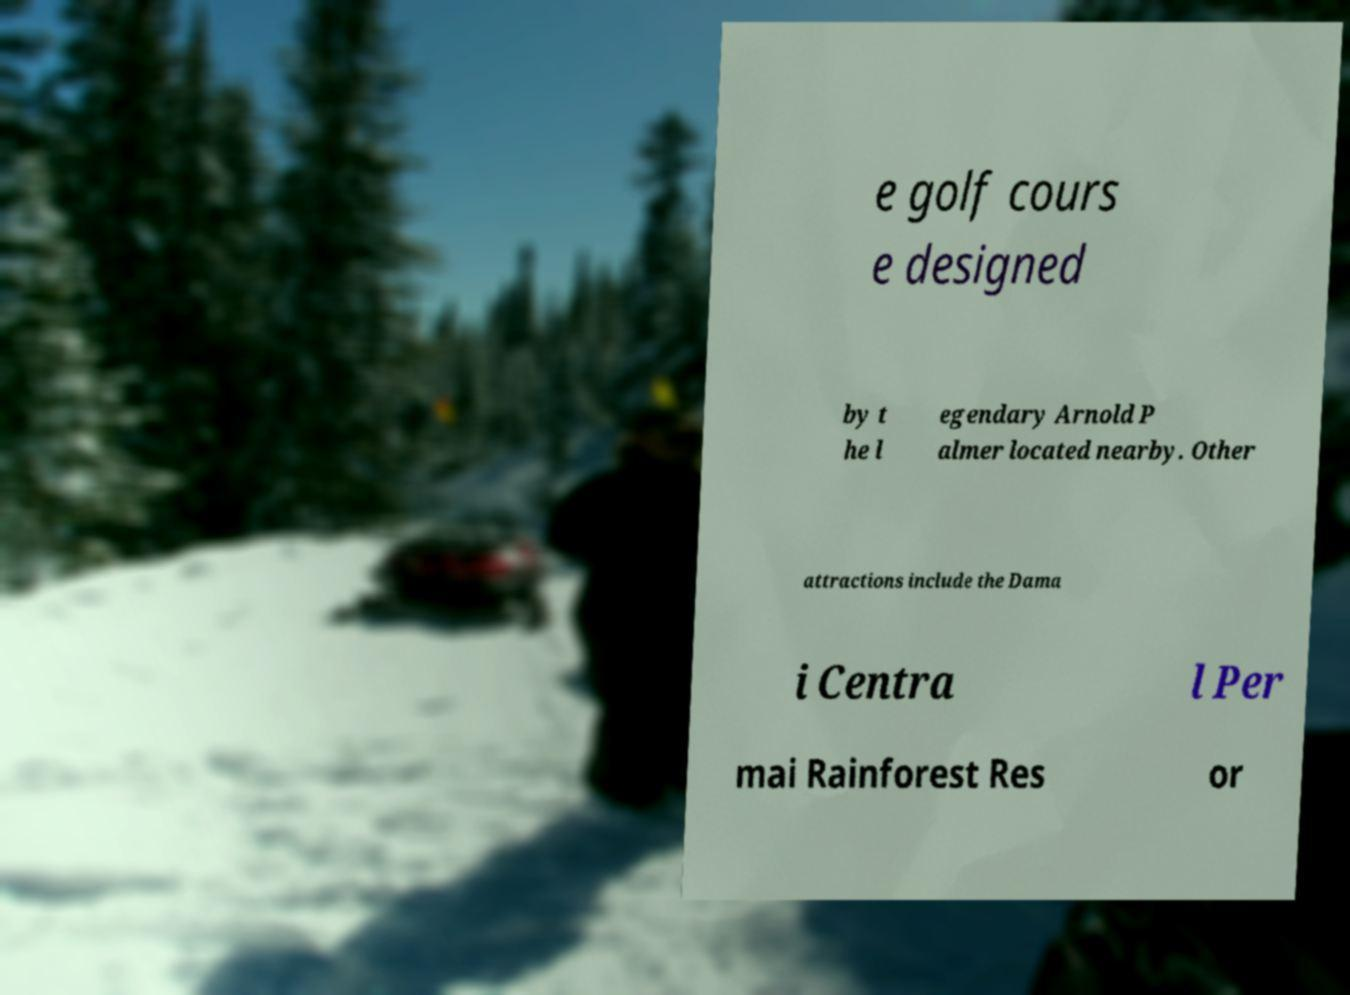Could you assist in decoding the text presented in this image and type it out clearly? e golf cours e designed by t he l egendary Arnold P almer located nearby. Other attractions include the Dama i Centra l Per mai Rainforest Res or 